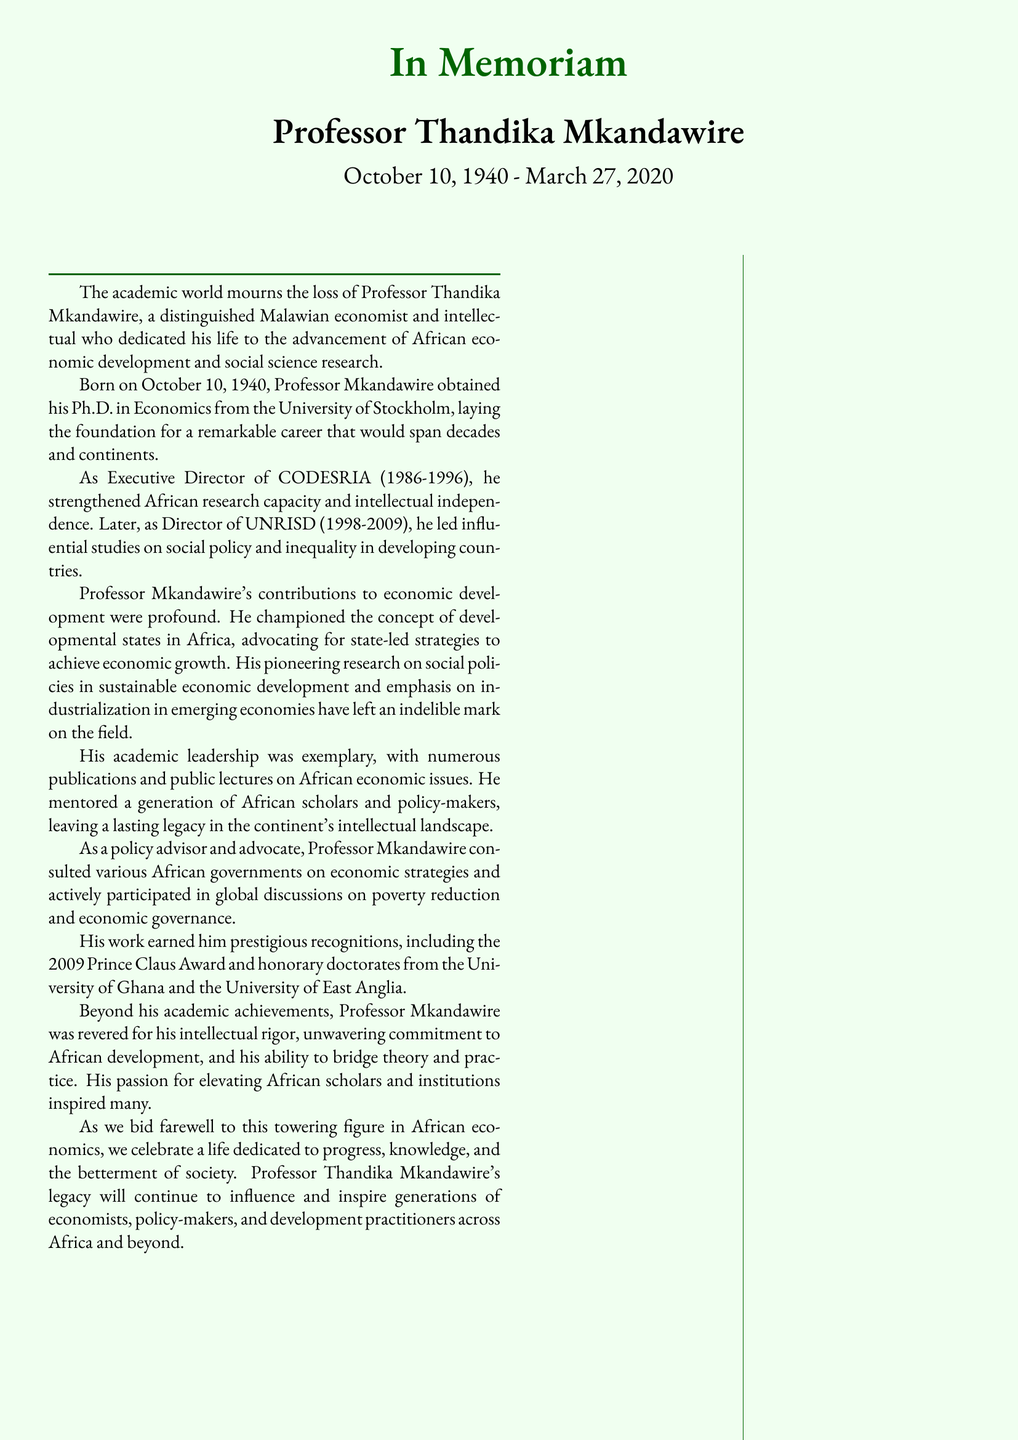What was the birth date of Professor Thandika Mkandawire? The document states that he was born on October 10, 1940.
Answer: October 10, 1940 What position did Professor Mkandawire hold from 1986 to 1996? The document mentions he was the Executive Director of CODESRIA during this period.
Answer: Executive Director of CODESRIA Which award did he receive in 2009? According to the document, he received the Prince Claus Award in that year.
Answer: Prince Claus Award What was one of his key contributions to African economics? The document lists several contributions, one being the promotion of developmental states in Africa.
Answer: Promoted developmental states in Africa Where did Professor Mkandawire complete his Ph.D.? The document specifies that he obtained his Ph.D. from the University of Stockholm.
Answer: University of Stockholm What was a significant theme in his research? The document highlights that he pioneered research on social policies in economic development.
Answer: Social policies in economic development Which institutions awarded him honorary doctorates? The document names the University of Ghana and the University of East Anglia as institutions that awarded him honorary doctorates.
Answer: University of Ghana and University of East Anglia In which area did Professor Mkandawire actively consult African governments? The document states he advised African governments on economic strategies.
Answer: Economic strategies What personal quality was he respected for? The document notes he was respected for his intellectual rigor.
Answer: Intellectual rigor 